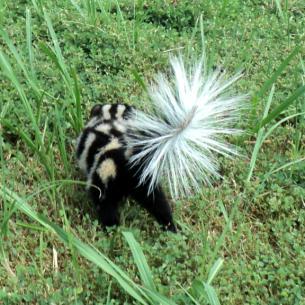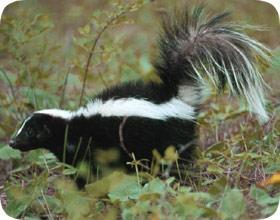The first image is the image on the left, the second image is the image on the right. Considering the images on both sides, is "The single skunk on the right has a bold straight white stripe and stands in profile, and the single skunk on the left has curving, maze-like stripes." valid? Answer yes or no. Yes. The first image is the image on the left, the second image is the image on the right. For the images shown, is this caption "One tail is a solid color." true? Answer yes or no. Yes. 